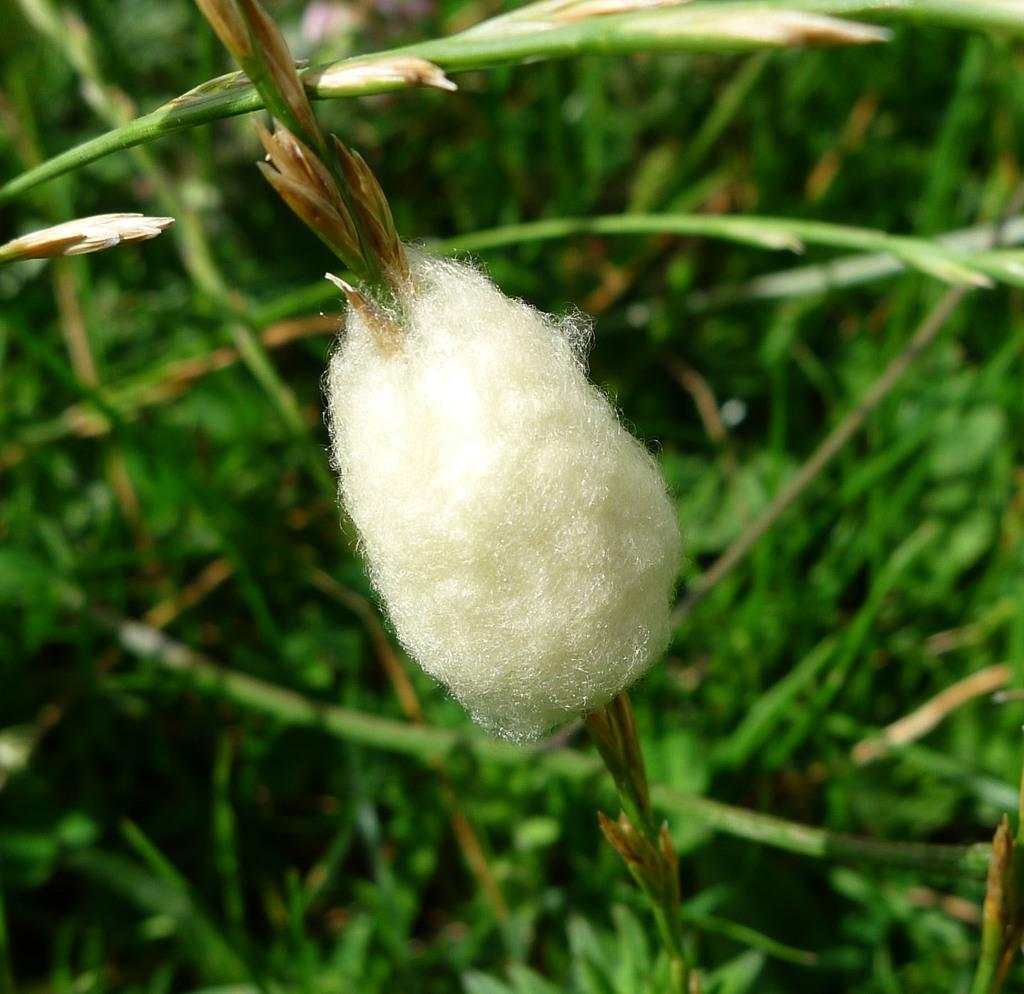What is the main subject of the image? The main subject of the image is a cocoon. Where is the cocoon located in the image? The cocoon is on the stem of a plant. How many chairs are visible in the image? There are no chairs present in the image. What type of voyage is the cocoon embarking on in the image? The image does not depict a voyage, and the cocoon is stationary on the stem of a plant. How many frogs can be seen interacting with the cocoon in the image? There are no frogs present in the image. 